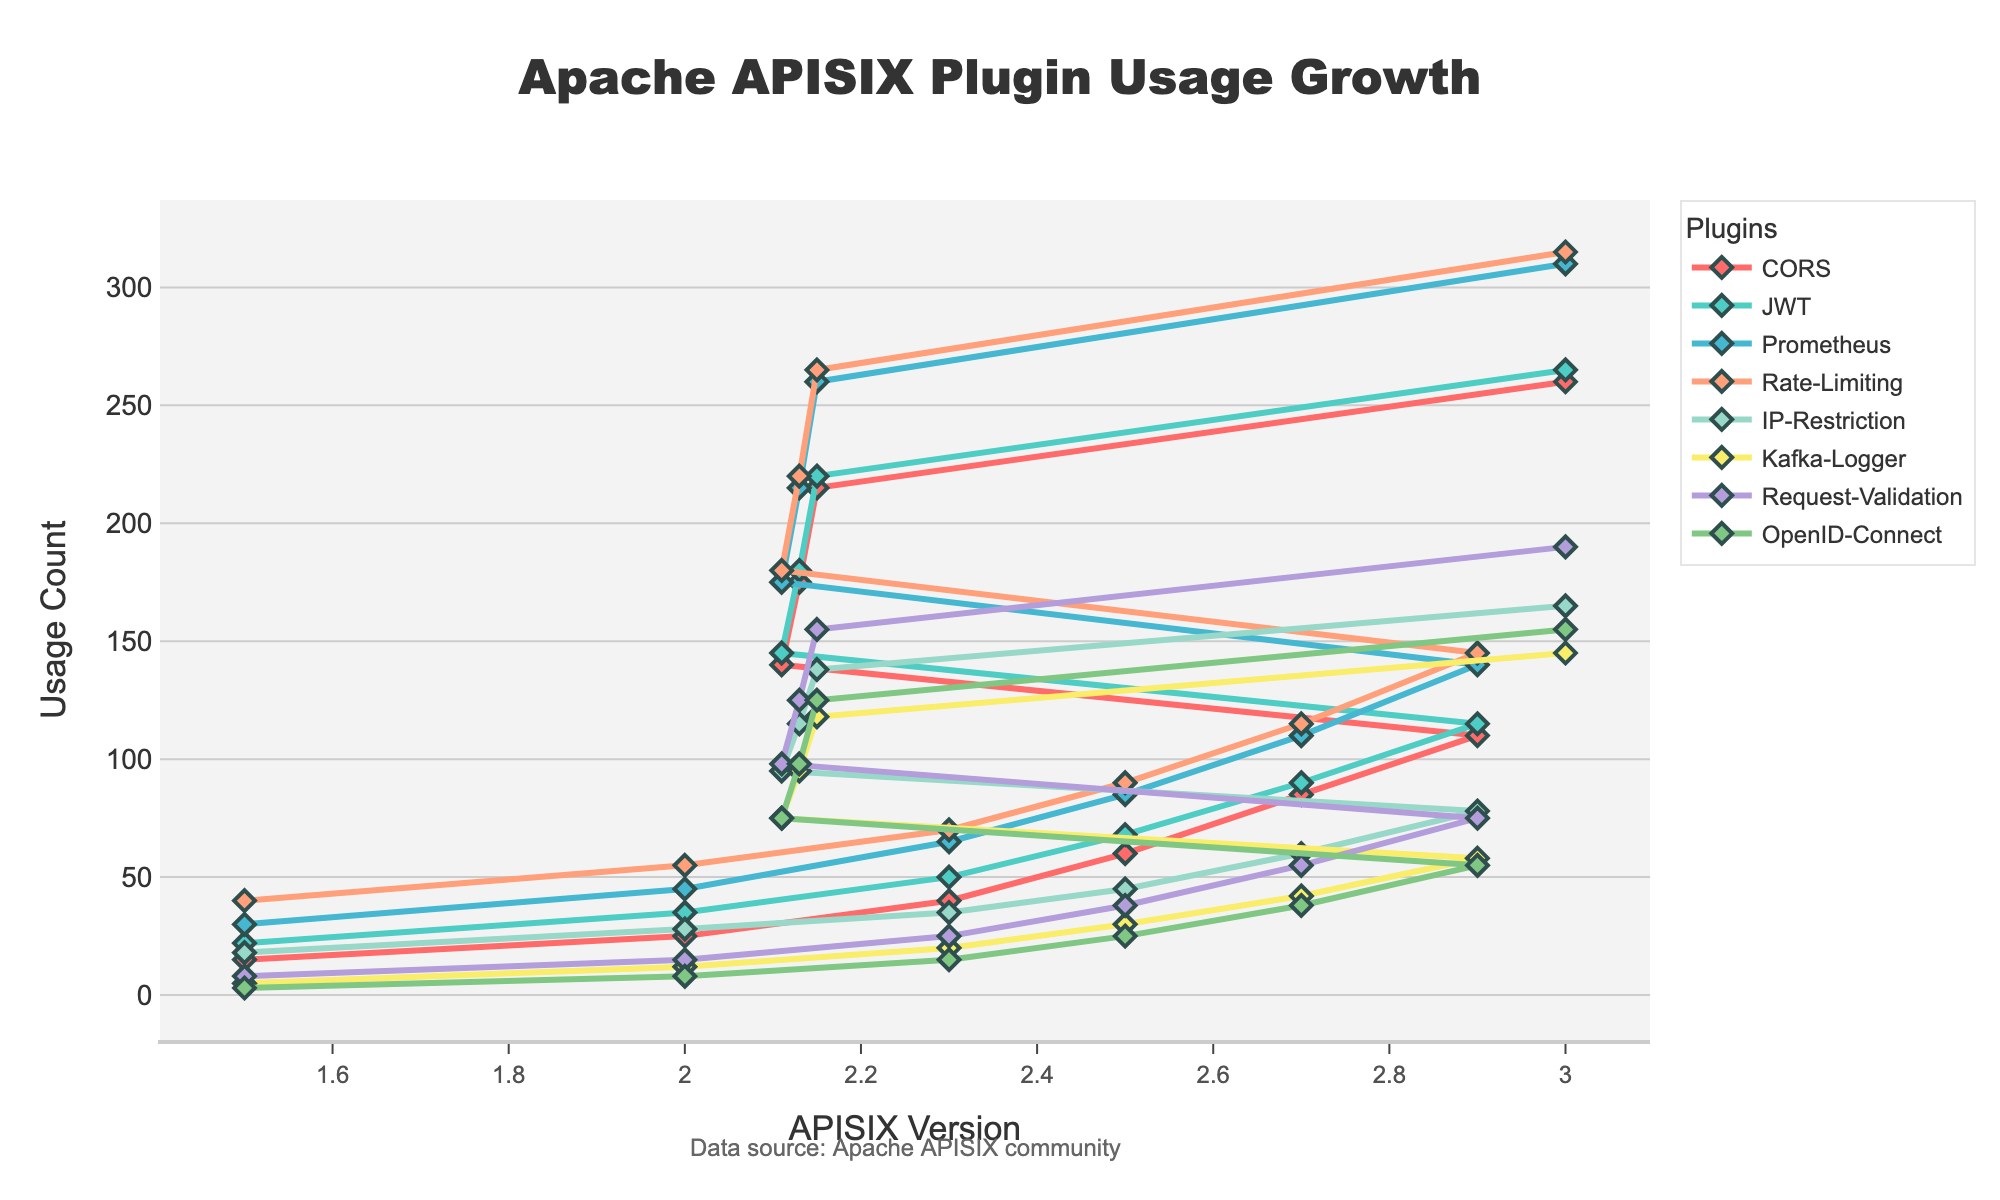What is the general trend of the CORS plugin usage from version 1.5 to 3.0? The line representing the CORS plugin in the plot shows an upward slope from version 1.5 to 3.0, indicating continuous growth.
Answer: Increasing Which plugin had the highest usage count in version 3.0? By looking at the y-values for version 3.0 across all plugins, the Prometheus plugin has the highest count, shown by its position at the top of the plot.
Answer: Prometheus How much did the usage of the Rate-Limiting plugin increase from version 1.5 to version 3.0? The Rate-Limiting plugin count was 40 in version 1.5 and 315 in version 3.0. The increase is 315 - 40 = 275.
Answer: 275 Which versions had the steepest increase in usage for the Kafka-Logger plugin? The plot shows the steepest slope for Kafka-Logger usage between versions 2.7 and 2.9. The increase in count from 42 to 58 is notably sharp.
Answer: Between 2.7 and 2.9 What is the difference in OpenID-Connect plugin usage between versions 2.0 and 3.0? The usage count for OpenID-Connect in version 2.0 was 8 and in version 3.0 it was 155. The difference is 155 - 8 = 147.
Answer: 147 Which plugin has the most consistent increase across all versions? By observing the slopes of each plugin line, the JWT plugin shows a consistent increase with no sudden steep inclines or plateaus in any version, indicating a steady growth.
Answer: JWT How many plugins crossed the 200 usage count mark by version 3.0? Reviewing the y-values at version 3.0, four plugins (CORS, JWT, Prometheus, and Rate-Limiting) have usage counts over 200.
Answer: 4 Compare the growth of Request-Validation and IP-Restriction plugins between versions 2.9 and 3.0. From version 2.9 to 3.0, Request-Validation increases from 75 to 190, a difference of 115. IP-Restriction grows from 78 to 165, a difference of 87. Request-Validation had a larger increase.
Answer: Request-Validation What was the usage count for the CORS and IP-Restriction plugins in version 2.7, and which one was higher? In version 2.7, CORS had a count of 85 and IP-Restriction had a count of 60. Thus, CORS was higher.
Answer: CORS What is the average usage of the Kafka-Logger plugin from version 1.5 to 3.0? Summing the Kafka-Logger counts: 5 + 12 + 20 + 30 + 42 + 58 + 75 + 95 + 118 + 145 = 600. Dividing by the number of versions (10), the average is 600/10 = 60.
Answer: 60 